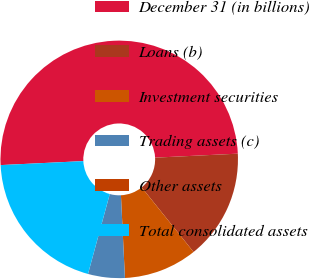<chart> <loc_0><loc_0><loc_500><loc_500><pie_chart><fcel>December 31 (in billions)<fcel>Loans (b)<fcel>Investment securities<fcel>Trading assets (c)<fcel>Other assets<fcel>Total consolidated assets<nl><fcel>50.0%<fcel>15.0%<fcel>10.0%<fcel>5.0%<fcel>0.0%<fcel>20.0%<nl></chart> 